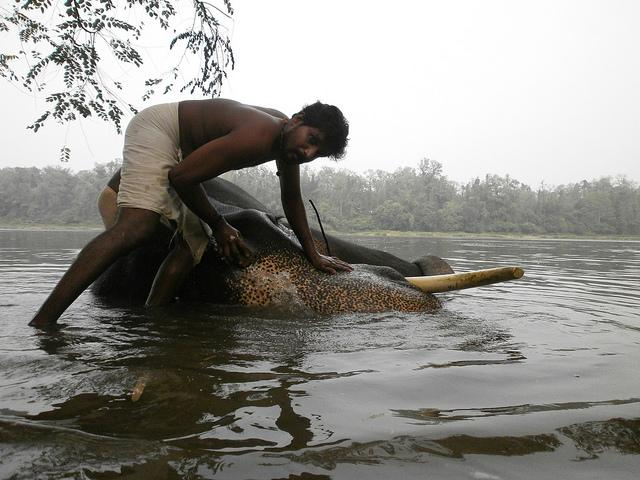What is the yellowish hard item sticking out from the animal? tusk 